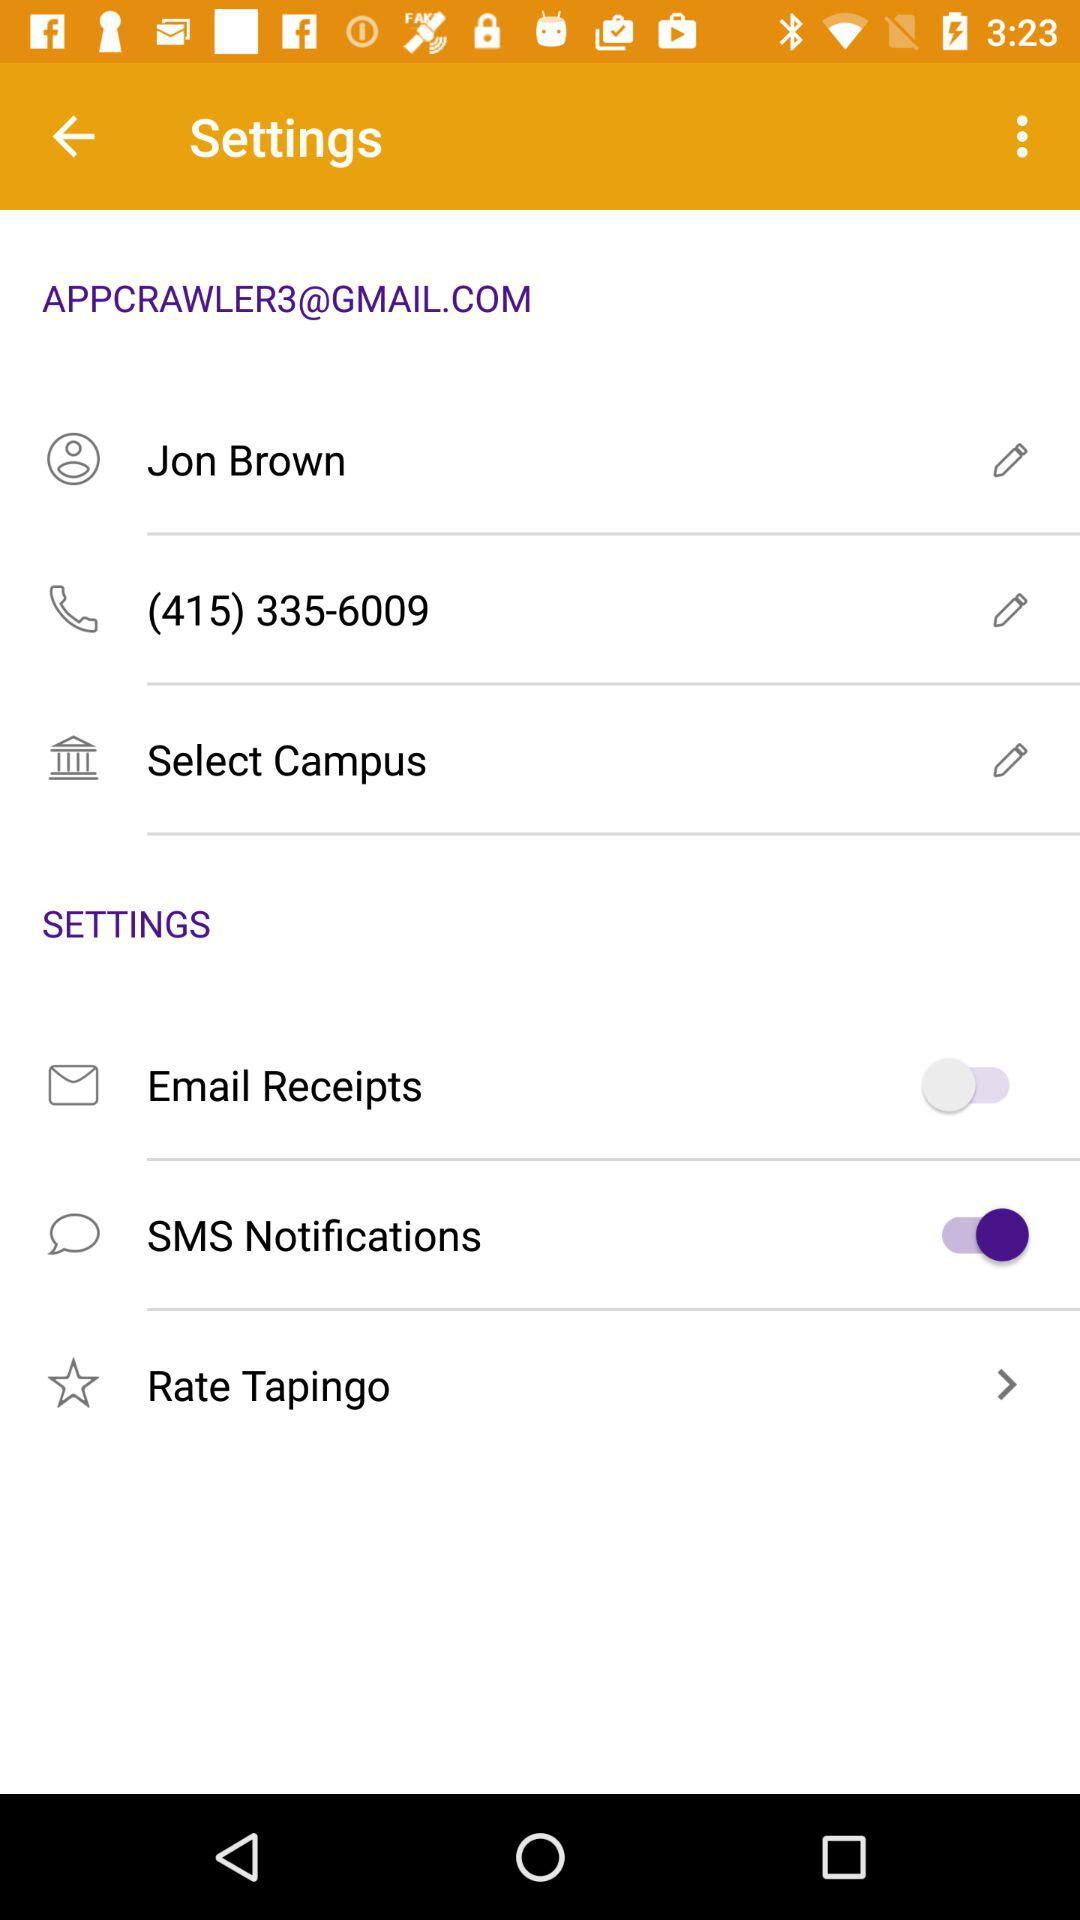What is the email address of the user? The email address is "APPCRAWLER3@GMAIL.COM". 